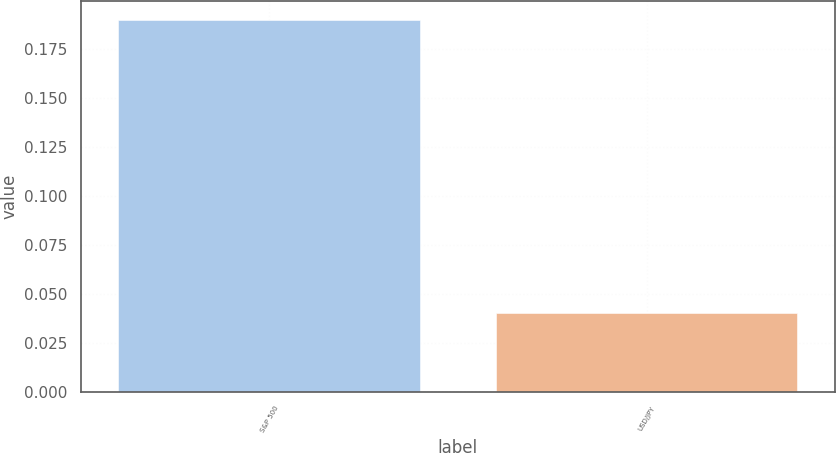Convert chart. <chart><loc_0><loc_0><loc_500><loc_500><bar_chart><fcel>S&P 500<fcel>USD/JPY<nl><fcel>0.19<fcel>0.04<nl></chart> 